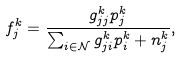Convert formula to latex. <formula><loc_0><loc_0><loc_500><loc_500>f ^ { k } _ { j } = \frac { g ^ { k } _ { j j } p _ { j } ^ { k } } { \sum _ { i \in \mathcal { N } } g ^ { k } _ { j i } p _ { i } ^ { k } + n _ { j } ^ { k } } ,</formula> 